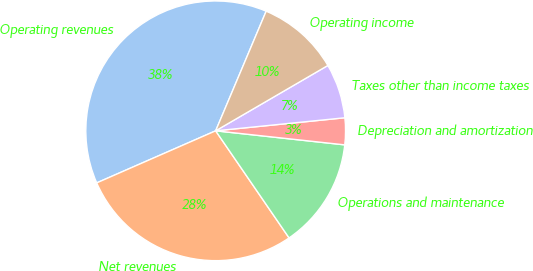<chart> <loc_0><loc_0><loc_500><loc_500><pie_chart><fcel>Operating revenues<fcel>Net revenues<fcel>Operations and maintenance<fcel>Depreciation and amortization<fcel>Taxes other than income taxes<fcel>Operating income<nl><fcel>37.93%<fcel>28.0%<fcel>13.71%<fcel>3.33%<fcel>6.79%<fcel>10.25%<nl></chart> 